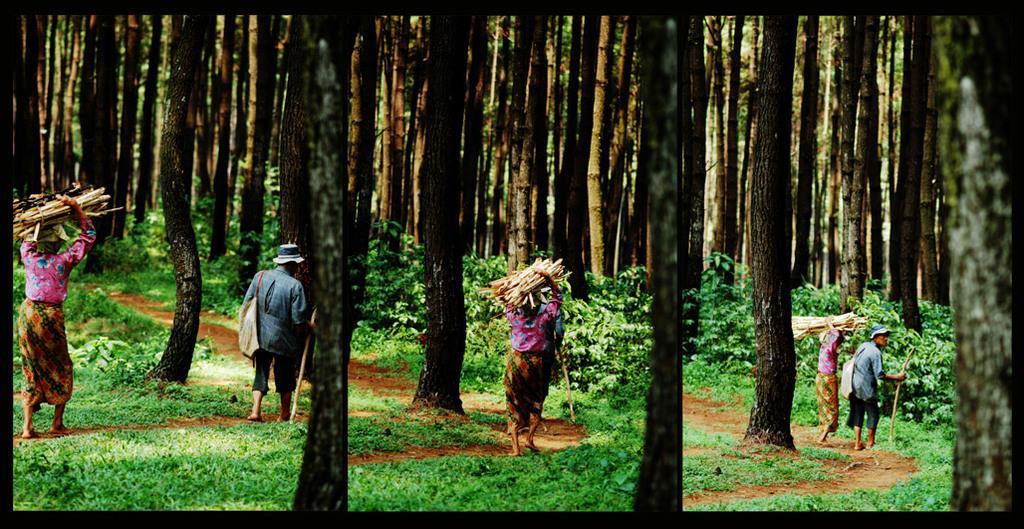Please provide a concise description of this image. This is a photo and here we can see people and some are holding logs and some are wearing caps, bags and holding sticks. In the background, there are trees and at the bottom, there are plants on the ground. 